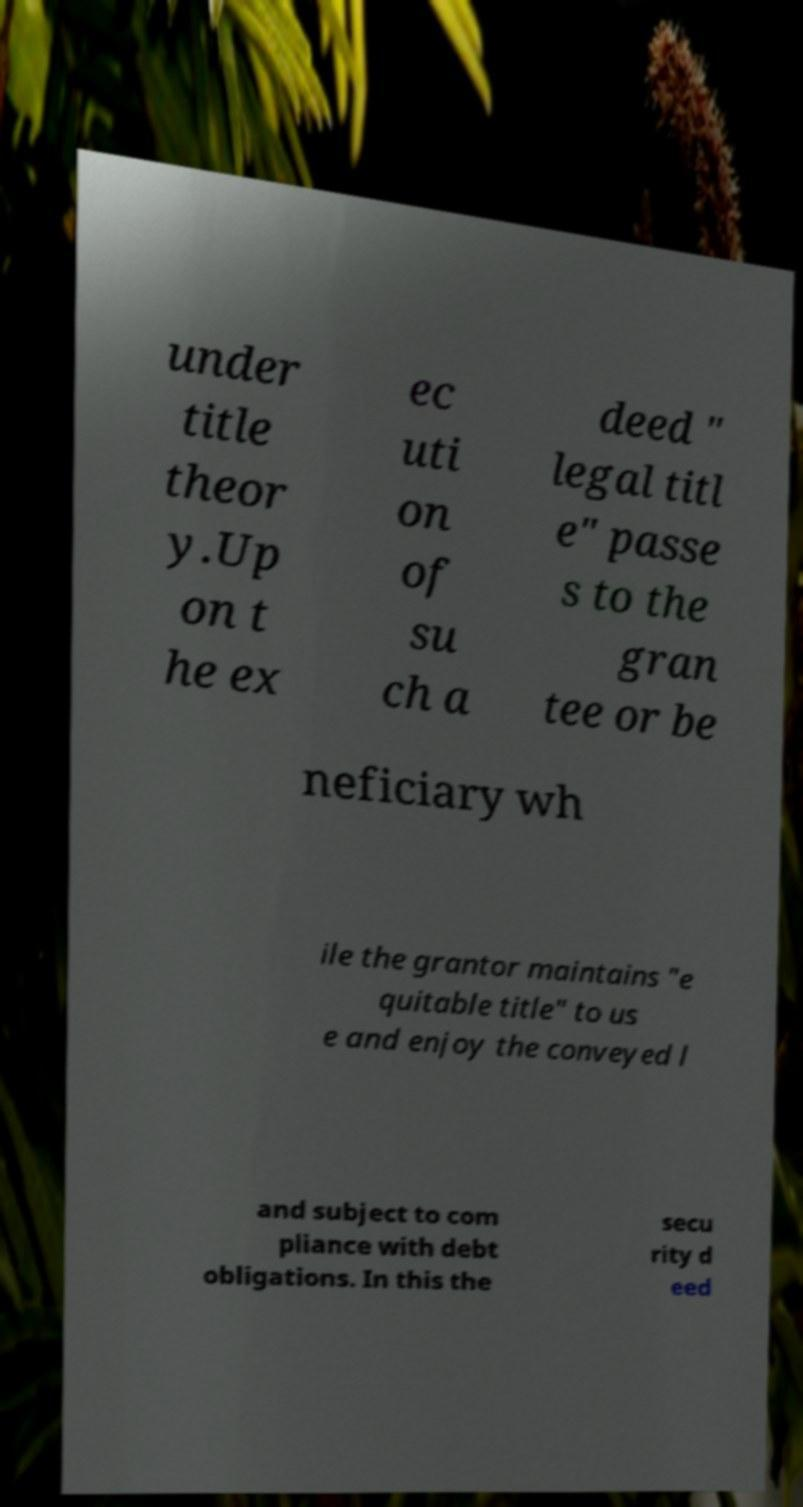Could you assist in decoding the text presented in this image and type it out clearly? under title theor y.Up on t he ex ec uti on of su ch a deed " legal titl e" passe s to the gran tee or be neficiary wh ile the grantor maintains "e quitable title" to us e and enjoy the conveyed l and subject to com pliance with debt obligations. In this the secu rity d eed 